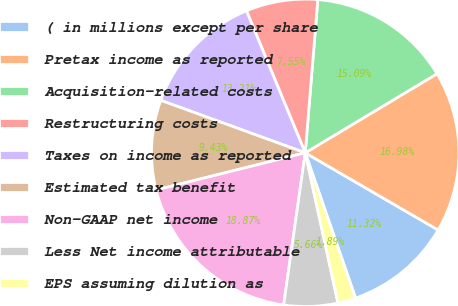Convert chart. <chart><loc_0><loc_0><loc_500><loc_500><pie_chart><fcel>( in millions except per share<fcel>Pretax income as reported<fcel>Acquisition-related costs<fcel>Restructuring costs<fcel>Taxes on income as reported<fcel>Estimated tax benefit<fcel>Non-GAAP net income<fcel>Less Net income attributable<fcel>EPS assuming dilution as<nl><fcel>11.32%<fcel>16.98%<fcel>15.09%<fcel>7.55%<fcel>13.21%<fcel>9.43%<fcel>18.87%<fcel>5.66%<fcel>1.89%<nl></chart> 